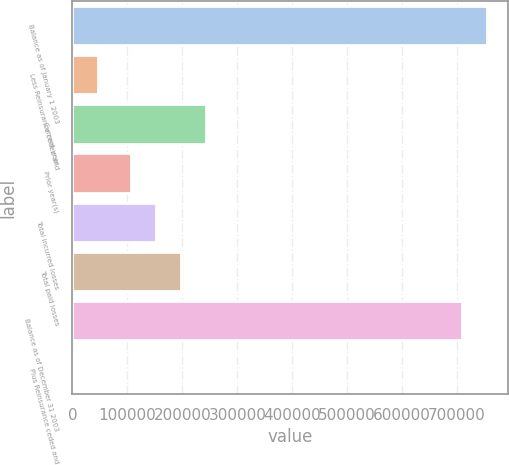Convert chart to OTSL. <chart><loc_0><loc_0><loc_500><loc_500><bar_chart><fcel>Balance as of January 1 2003<fcel>Less Reinsurance ceded and<fcel>Current year<fcel>Prior year(s)<fcel>Total incurred losses<fcel>Total paid losses<fcel>Balance as of December 31 2003<fcel>Plus Reinsurance ceded and<nl><fcel>754614<fcel>45697.4<fcel>243610<fcel>106629<fcel>152289<fcel>197950<fcel>708954<fcel>37<nl></chart> 